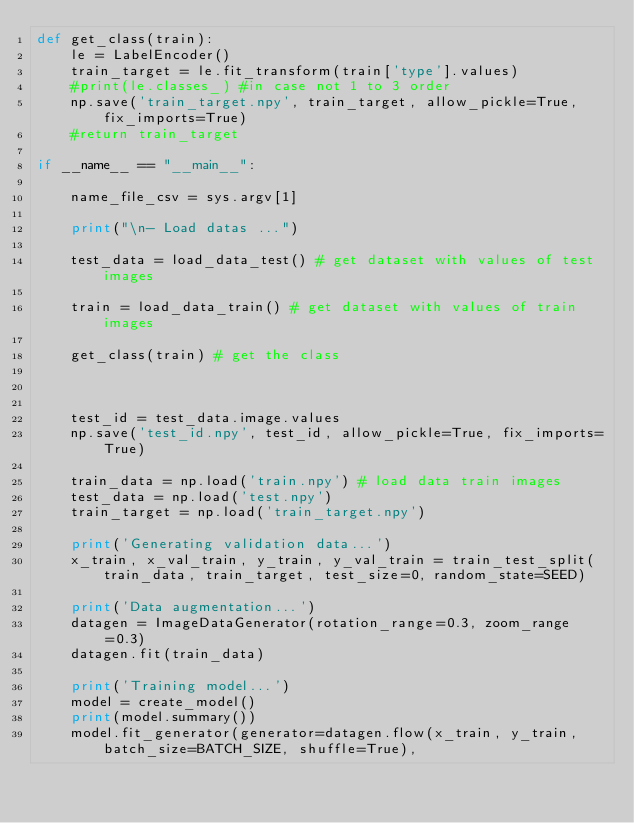<code> <loc_0><loc_0><loc_500><loc_500><_Python_>def get_class(train):
    le = LabelEncoder()
    train_target = le.fit_transform(train['type'].values)
    #print(le.classes_) #in case not 1 to 3 order
    np.save('train_target.npy', train_target, allow_pickle=True, fix_imports=True)
    #return train_target

if __name__ == "__main__":

    name_file_csv = sys.argv[1]

    print("\n- Load datas ...")

    test_data = load_data_test() # get dataset with values of test images

    train = load_data_train() # get dataset with values of train images

    get_class(train) # get the class



    test_id = test_data.image.values
    np.save('test_id.npy', test_id, allow_pickle=True, fix_imports=True)

    train_data = np.load('train.npy') # load data train images
    test_data = np.load('test.npy')
    train_target = np.load('train_target.npy')

    print('Generating validation data...')
    x_train, x_val_train, y_train, y_val_train = train_test_split(train_data, train_target, test_size=0, random_state=SEED)

    print('Data augmentation...')
    datagen = ImageDataGenerator(rotation_range=0.3, zoom_range=0.3)
    datagen.fit(train_data)

    print('Training model...')
    model = create_model()
    print(model.summary())
    model.fit_generator(generator=datagen.flow(x_train, y_train, batch_size=BATCH_SIZE, shuffle=True),</code> 